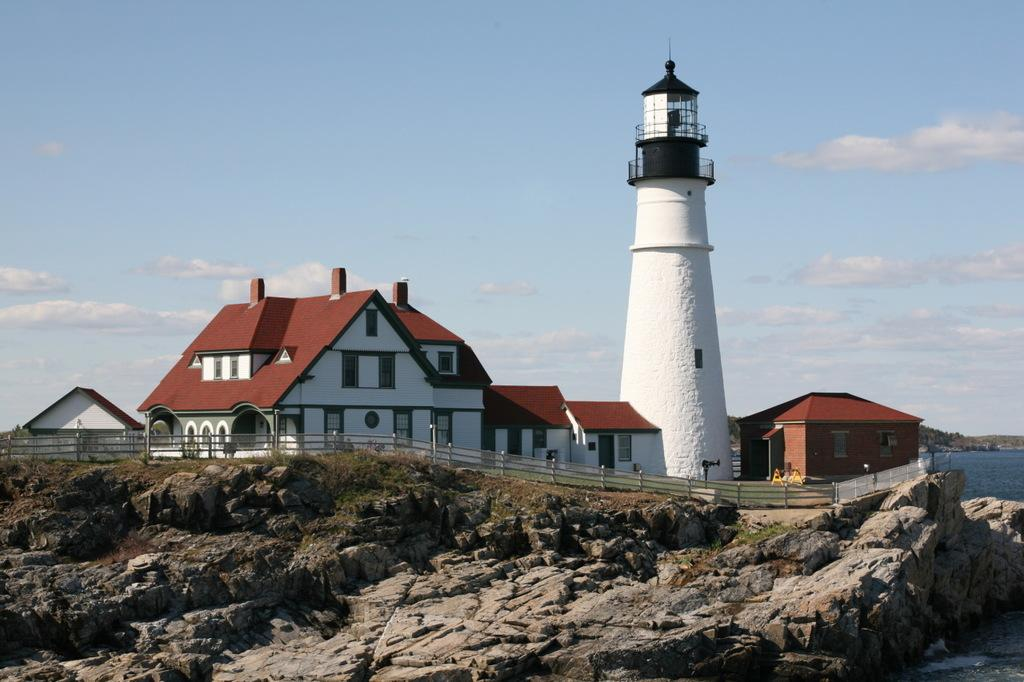What is the main structure in the center of the image? There is a lighthouse in the center of the image. What else can be seen in the center of the image besides the lighthouse? There are houses in the center of the image. What is located at the bottom of the image? There is fencing and water visible at the bottom of the image, along with stones. What is visible in the background of the image? Water and the sky are visible in the background of the image, along with clouds. What type of rail can be seen connecting the lighthouse to the houses in the image? There is no rail connecting the lighthouse to the houses in the image. What kind of waste is being disposed of in the water at the bottom of the image? There is no waste visible in the water at the bottom of the image. 